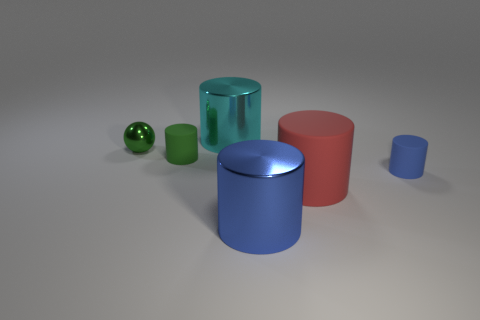Is the number of cyan metal things that are in front of the large cyan cylinder greater than the number of big cyan metallic cylinders?
Offer a terse response. No. How many balls have the same size as the green rubber object?
Give a very brief answer. 1. There is a blue cylinder that is behind the blue metal thing; is its size the same as the blue cylinder on the left side of the big matte cylinder?
Offer a terse response. No. How big is the ball left of the large blue thing?
Provide a succinct answer. Small. There is a rubber object behind the tiny rubber cylinder to the right of the large cyan metallic thing; what is its size?
Offer a terse response. Small. There is a cyan thing that is the same size as the blue shiny thing; what is it made of?
Your answer should be very brief. Metal. Are there any small things to the left of the blue matte object?
Your answer should be compact. Yes. Are there an equal number of big metal cylinders behind the small green rubber cylinder and matte objects?
Ensure brevity in your answer.  No. What shape is the metal object that is the same size as the blue matte object?
Offer a terse response. Sphere. What material is the red object?
Ensure brevity in your answer.  Rubber. 